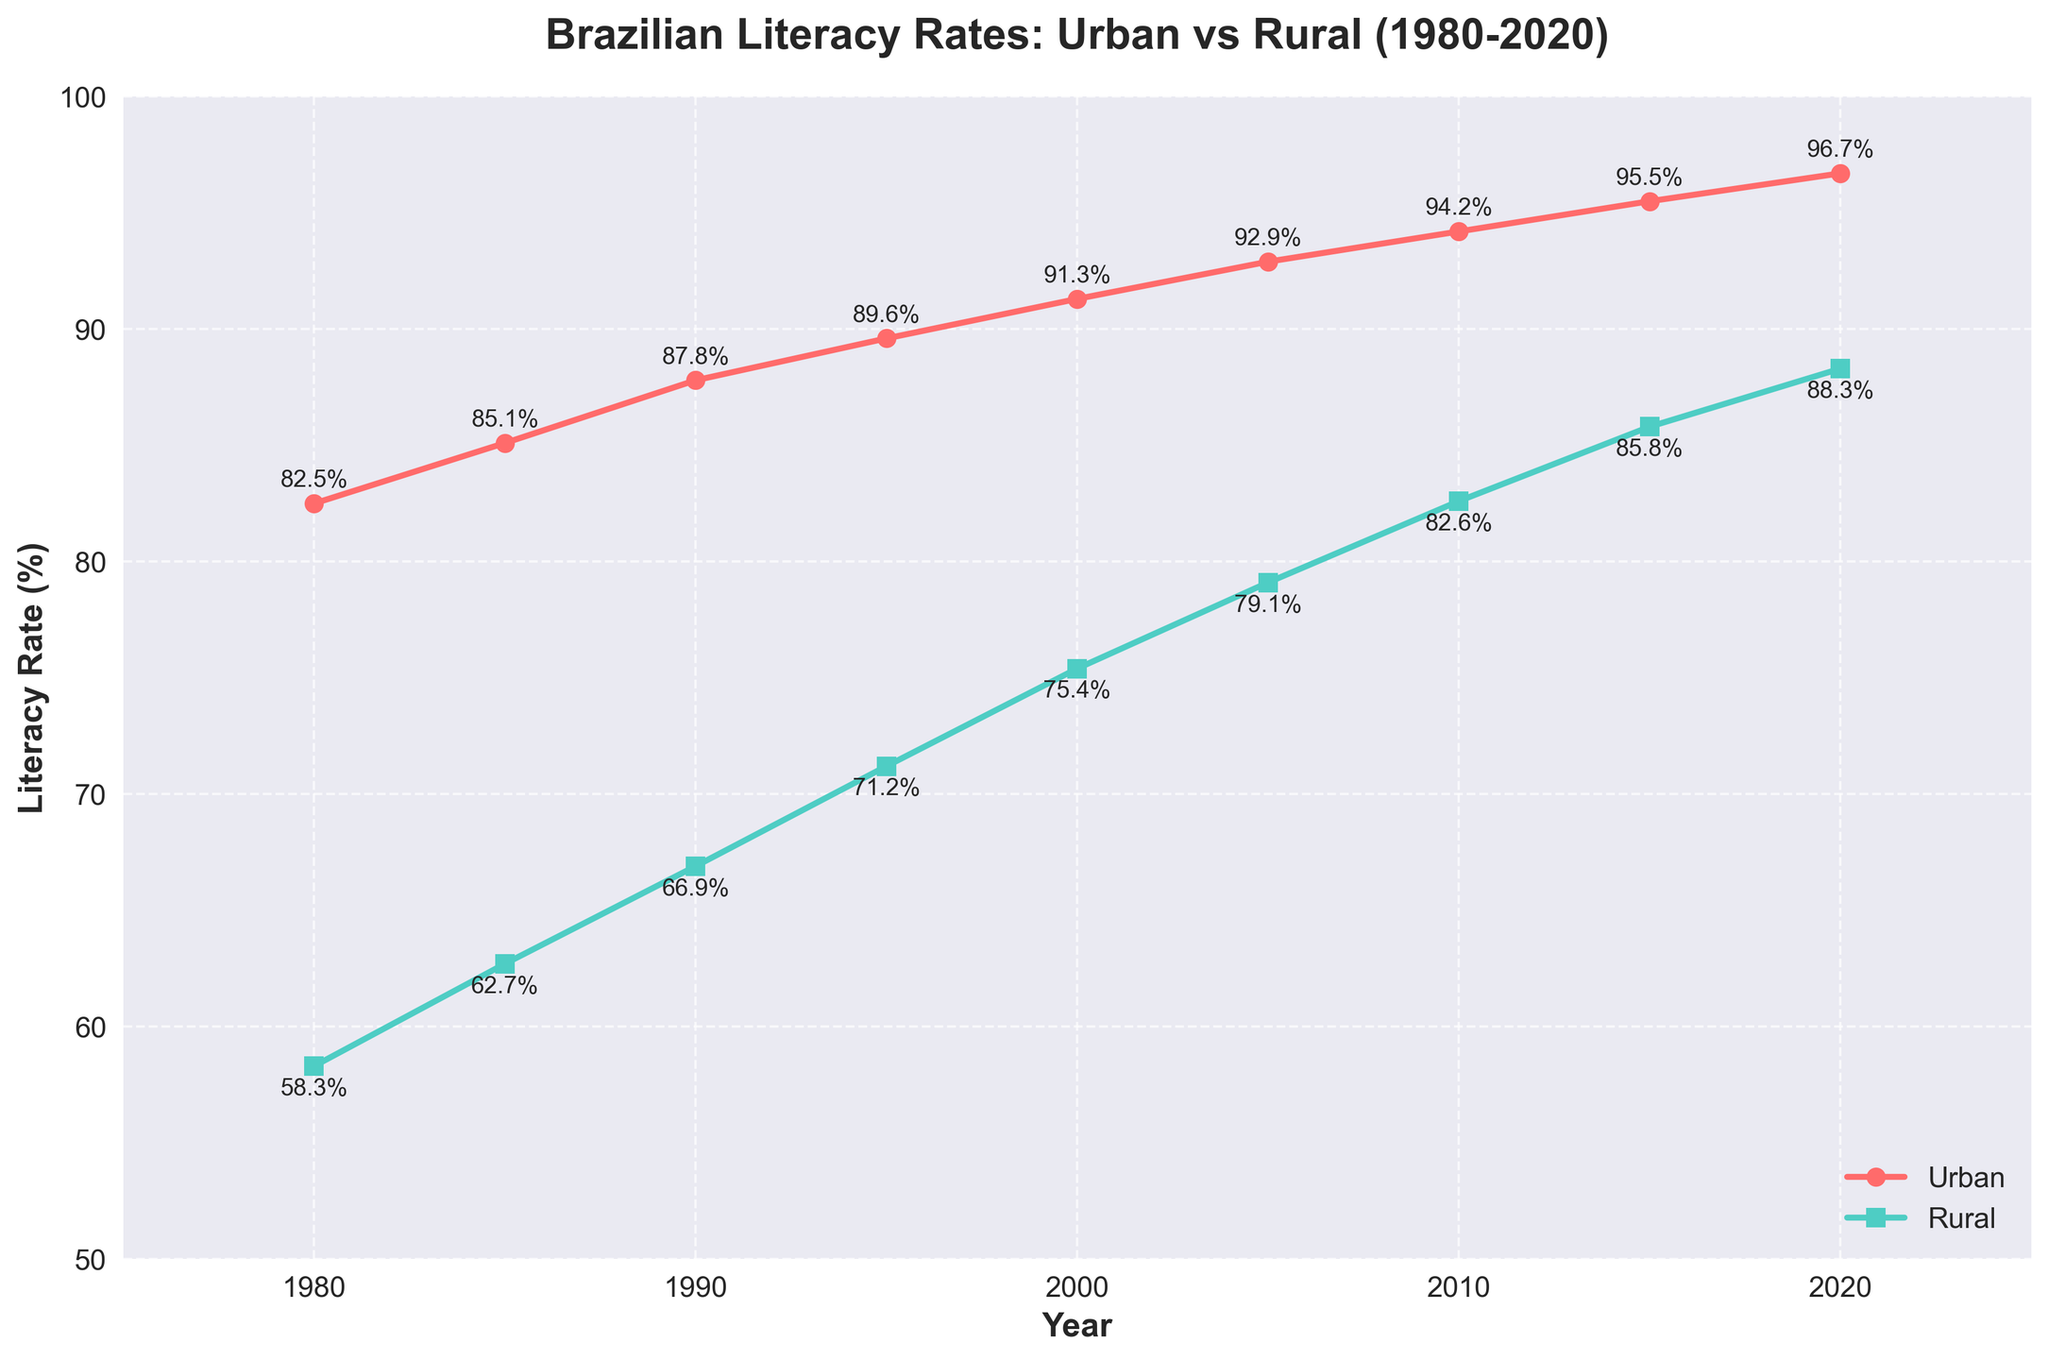What is the overall trend in urban literacy rates from 1980 to 2020? The figure shows a steadily increasing trend in urban literacy rates from 82.5% in 1980 to 96.7% in 2020. By observing the line labeled 'Urban', the literacy rate consistently increases across all the years.
Answer: Steadily increasing Which year had a higher rural literacy rate, 1985 or 2000? The green line marked with squares represents rural literacy rates, showing 62.7% in 1985 and 75.4% in 2000. Comparing these percentages, 2000 had a higher rural literacy rate.
Answer: 2000 What is the difference between urban and rural literacy rates in 2010? According to the chart, the urban literacy rate in 2010 was 94.2%, and the rural literacy rate was 82.6%. Subtracting the rural rate from the urban rate gives 94.2% - 82.6% = 11.6%.
Answer: 11.6% By how much did the rural literacy rate increase from 1980 to 2020? The rural literacy rate was 58.3% in 1980 and increased to 88.3% in 2020. The increase is calculated as 88.3% - 58.3% = 30%.
Answer: 30% How many years did it take for the urban literacy rate to go from 85.1% to over 90%? The urban literacy rate surpassed 90% between 1985 (85.1%) and 1995 (89.6%). By checking the 'Urban' line, we see it reached 91.3% in 2000. So it took from 1985 to 2000, which is 15 years, to exceed 90%.
Answer: 15 years Was there any year between 1980 and 2020 where the urban literacy rate was lower than the rural literacy rate? By observing both lines, the urban literacy rate (red line) is consistently higher than the rural literacy rate at every data point between 1980 and 2020.
Answer: No Which color represents urban literacy rates? The color red represents the urban literacy rates, as shown by the line with circular markers.
Answer: Red During which period did rural literacy rates experience the largest increase, and by how much? The rural literacy rate saw the largest increase between 2000 and 2005. In 2000, it was 75.4%, and in 2005, it was 79.1%, resulting in an increase of 3.7%.
Answer: 2000-2005, 3.7% What is the average literacy rate for urban areas between 1980 and 2020? Urban literacy rates are given for ten different years: 82.5%, 85.1%, 87.8%, 89.6%, 91.3%, 92.9%, 94.2%, 95.5%, and 96.7%. Summing these values gives 815.6%, and averaging them by dividing by the number of values (9), we get 90.62%.
Answer: 90.62% How does the gap between urban and rural literacy rates change over the years? The gap between urban and rural literacy rates decreases over time. In 1980, the difference was 82.5% - 58.3% = 24.2%, and in 2020, it reduced to 96.7% - 88.3% = 8.4%, showing that the rural literacy rate is catching up with urban literacy rates.
Answer: Decreases 